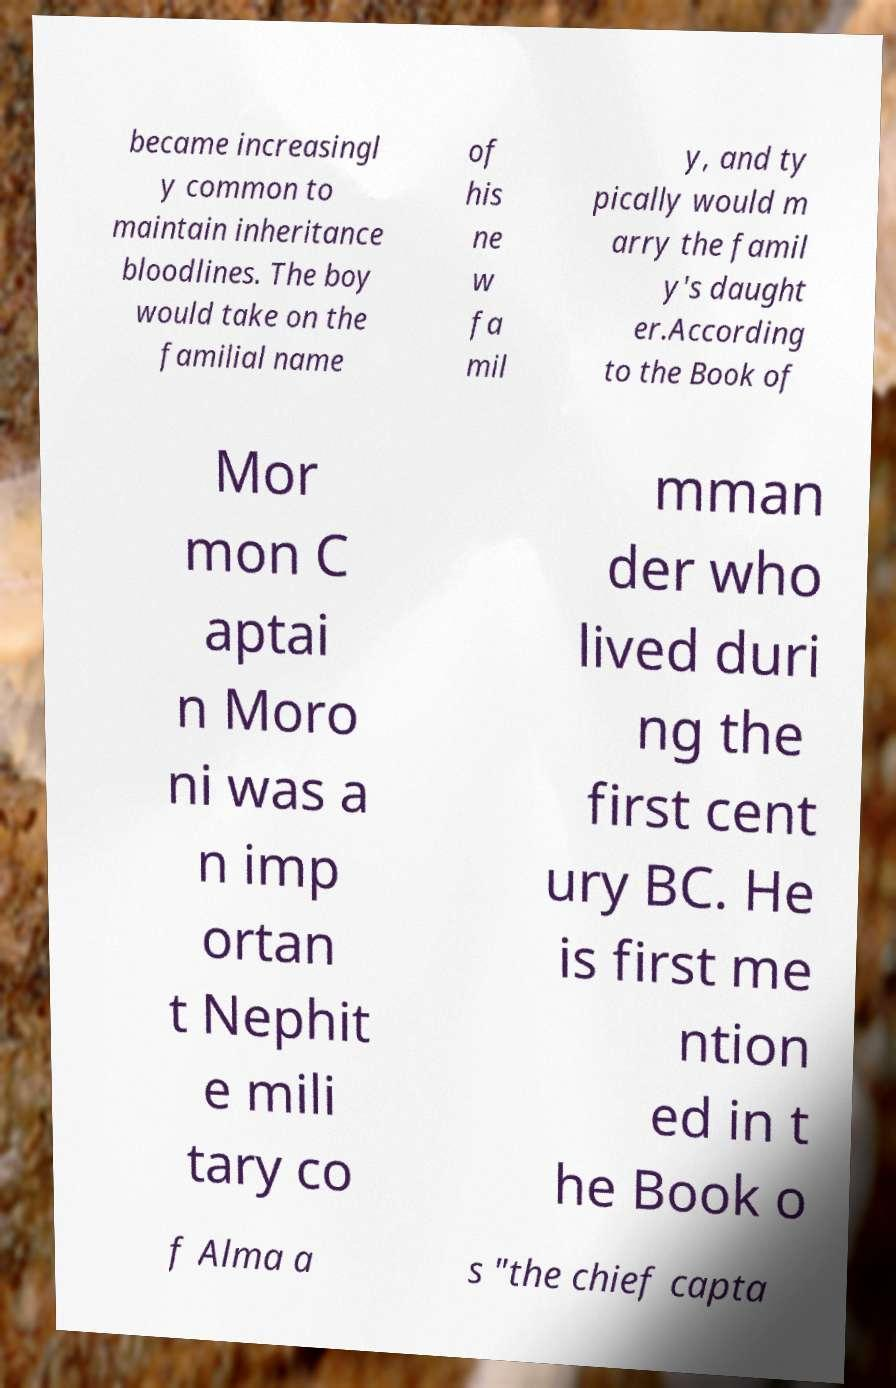Could you assist in decoding the text presented in this image and type it out clearly? became increasingl y common to maintain inheritance bloodlines. The boy would take on the familial name of his ne w fa mil y, and ty pically would m arry the famil y's daught er.According to the Book of Mor mon C aptai n Moro ni was a n imp ortan t Nephit e mili tary co mman der who lived duri ng the first cent ury BC. He is first me ntion ed in t he Book o f Alma a s "the chief capta 